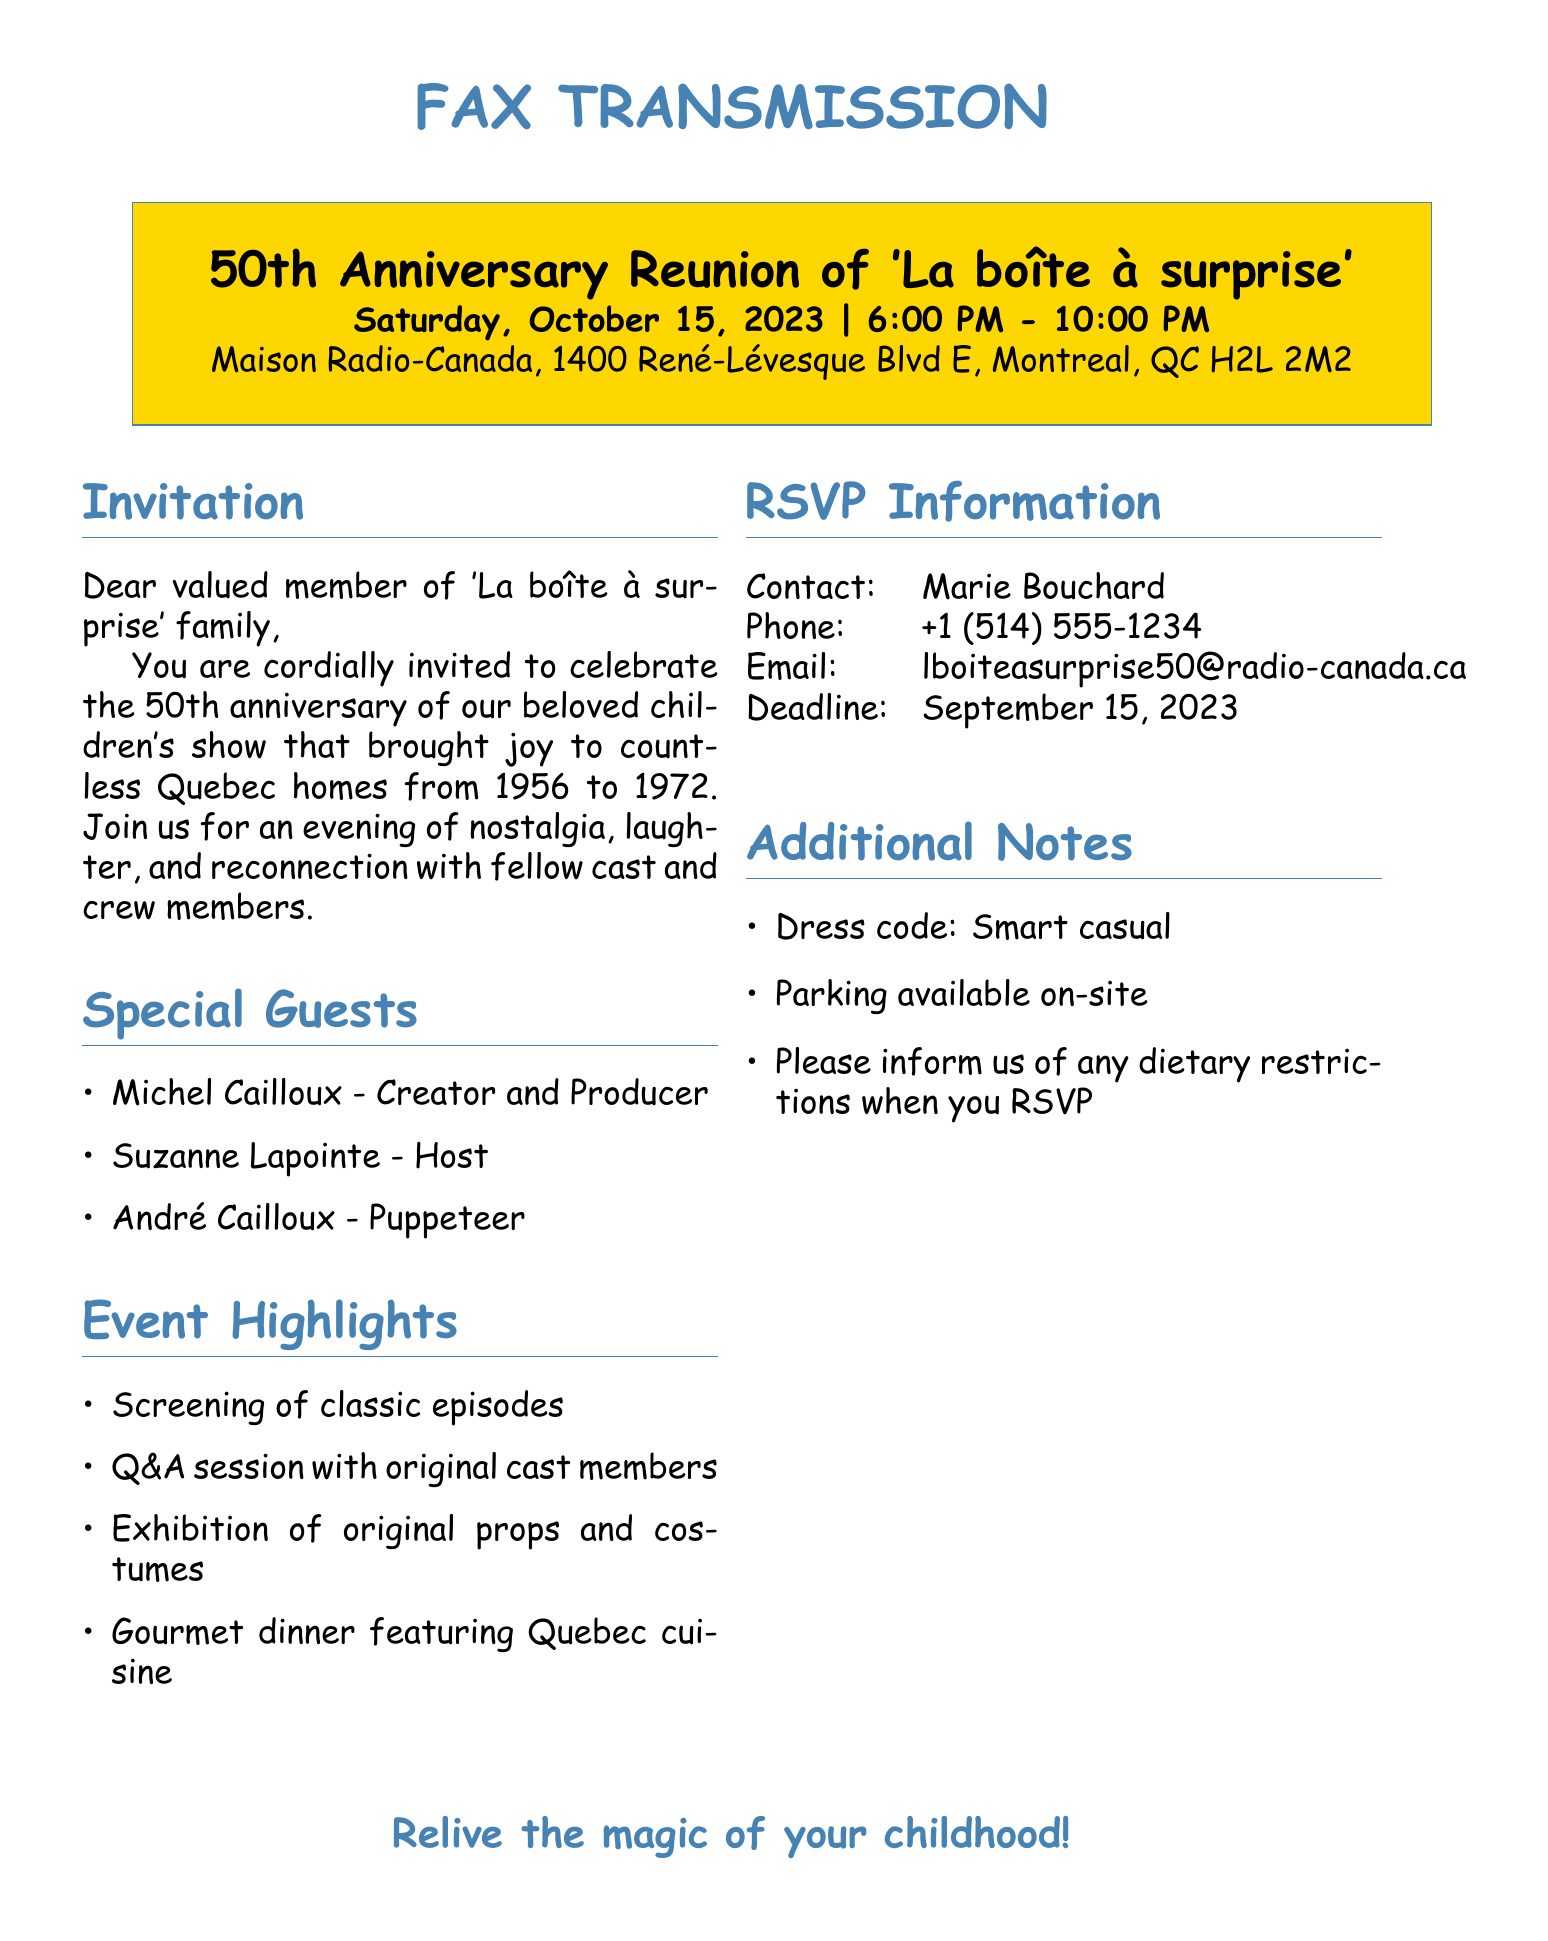What is the date of the reunion? The document clearly states the date of the reunion, which is October 15, 2023.
Answer: October 15, 2023 What time does the event start? The document specifies that the event begins at 6:00 PM.
Answer: 6:00 PM Where is the reunion taking place? The document provides the location as Maison Radio-Canada, 1400 René-Lévesque Blvd E, Montreal, QC H2L 2M2.
Answer: Maison Radio-Canada Who is one of the special guests? The document lists several special guests, including Michel Cailloux.
Answer: Michel Cailloux What type of cuisine will be served during the event? The document mentions that a gourmet dinner featuring Quebec cuisine will be served.
Answer: Quebec cuisine How should attendees dress for the event? The document specifies that the dress code is smart casual.
Answer: Smart casual What is the RSVP deadline? The document indicates that the RSVP deadline is September 15, 2023.
Answer: September 15, 2023 Is parking available at the venue? Yes, the document states that parking is available on-site.
Answer: Yes 